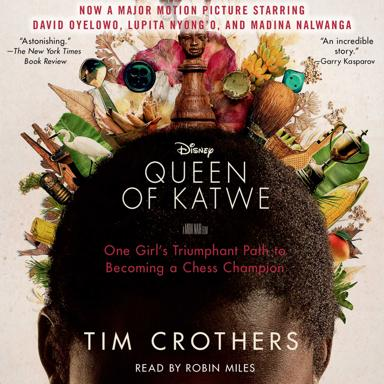What is the name of the major motion picture mentioned in the image? The major motion picture featured in the image is 'Queen of Katwe', a striking film produced by Disney, which showcases a compelling true story of triumph and determination. 